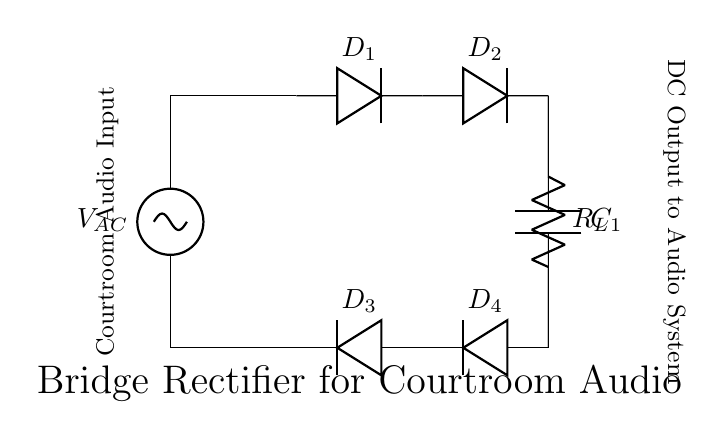What is the type of circuit shown? The circuit diagram illustrates a bridge rectifier, which is specifically designed to convert alternating current (AC) to direct current (DC). This type of configuration uses four diodes arranged in a bridge format.
Answer: Bridge rectifier How many diodes are used in this circuit? The circuit comprises four diodes labeled as D1, D2, D3, and D4. Each diode plays a crucial role in the rectification process by allowing current to flow in one direction.
Answer: Four What is the function of the capacitor in this circuit? The capacitor, labeled C1, is used for smoothing the output DC voltage by filtering out ripples that occur after the rectification process. It reduces fluctuations and provides a steadier DC output.
Answer: Smoothing What is the name of the component labeled R_L? R_L represents the load resistor connected at the output of the rectifier circuit. It is where the rectified DC power is delivered for the intended application, in this case, an audio system.
Answer: Load resistor What is the input of this circuit identified as? The AC source is indicated as V_AC, which is the input voltage supply that provides alternating current to the bridge rectifier for conversion to direct current.
Answer: V_AC What happens to the current direction when the AC input changes? When the AC supply alternates, the diodes in the bridge rectifier allow current to pass through them in such a way that the output remains positive regardless of the input cycle, thus maintaining a unidirectional flow of current.
Answer: Current remains positive What is the output of this circuit used for? The DC output generated from this bridge rectifier circuit is intended to power the courtroom audio system, ensuring that the devices receive a stable and continuous voltage supply for operation.
Answer: Courtroom audio system 